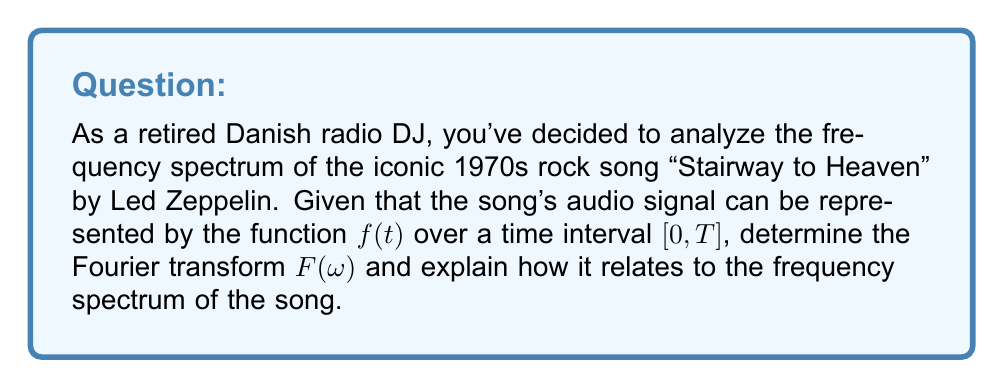Can you solve this math problem? To determine the frequency spectrum of "Stairway to Heaven" using Fourier transforms, we'll follow these steps:

1) The Fourier transform $F(\omega)$ of a continuous-time signal $f(t)$ is given by:

   $$F(\omega) = \int_{-\infty}^{\infty} f(t) e^{-i\omega t} dt$$

2) Since our audio signal $f(t)$ is defined over the interval $[0, T]$, we adjust our integral limits:

   $$F(\omega) = \int_{0}^{T} f(t) e^{-i\omega t} dt$$

3) The Fourier transform $F(\omega)$ gives us the frequency domain representation of the time-domain signal $f(t)$. Here, $\omega$ represents angular frequency in radians per second.

4) To get the frequency in Hz, we use the relation $f = \frac{\omega}{2\pi}$.

5) The magnitude of $F(\omega)$, denoted as $|F(\omega)|$, represents the amplitude of each frequency component in the signal. This is what we typically visualize in a frequency spectrum.

6) The frequency spectrum of "Stairway to Heaven" would show peaks at frequencies corresponding to the musical notes and harmonics present in the song. For instance:
   - The low frequencies (20-250 Hz) would represent the bass guitar and kick drum.
   - Mid-range frequencies (250-2000 Hz) would capture most of the guitar and vocal content.
   - Higher frequencies (2000-20000 Hz) would represent cymbals, guitar harmonics, and add "brilliance" to the overall sound.

7) To visualize the frequency spectrum, we would typically plot $|F(\omega)|$ against $\omega$ or $f$.

This analysis would allow you, as a retired DJ, to see the frequency components that give "Stairway to Heaven" its distinctive sound, and compare it to other rock songs from the 1970s.
Answer: $F(\omega) = \int_{0}^{T} f(t) e^{-i\omega t} dt$, where $|F(\omega)|$ represents the amplitude of each frequency component. 